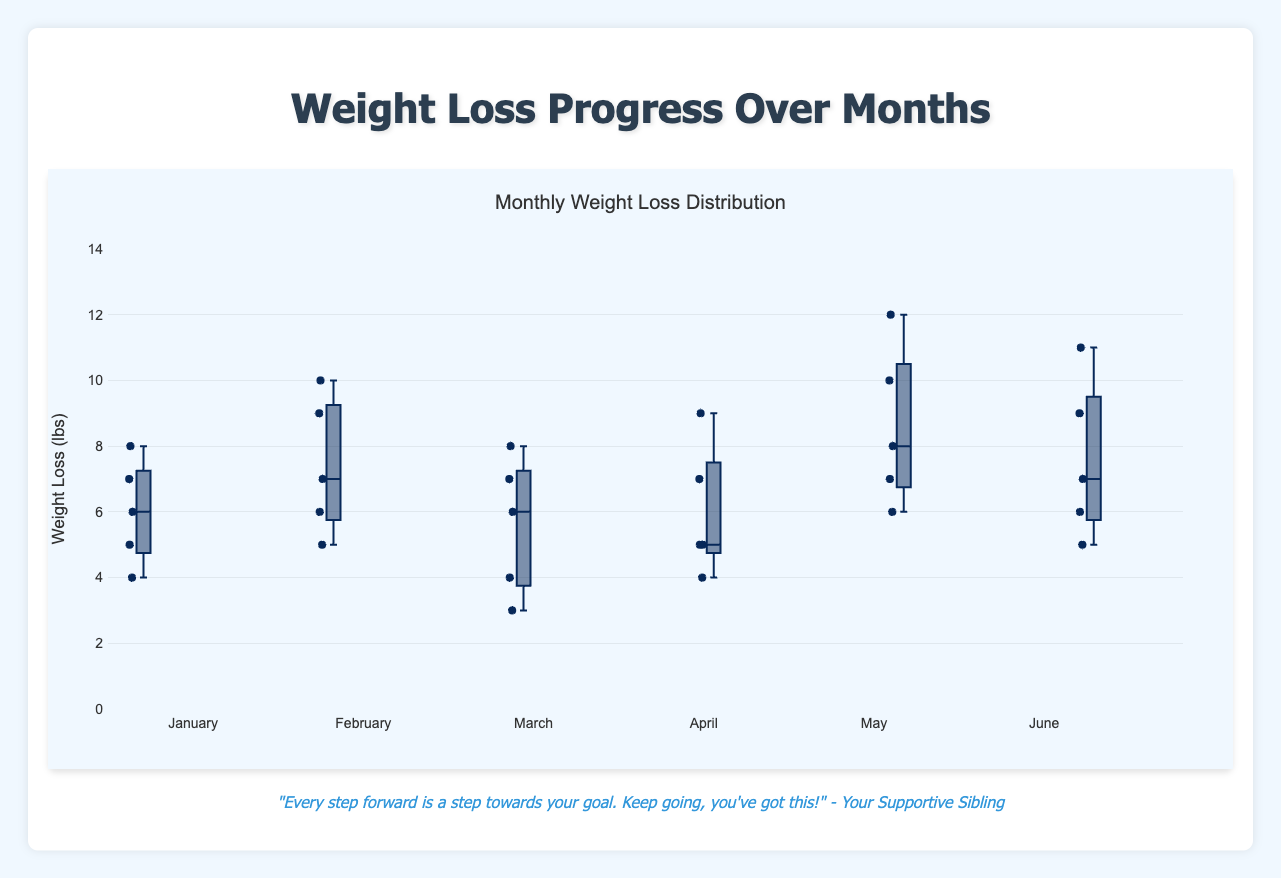What's the title of the plot? The title of the plot is located at the top of the chart and clearly indicates the content of the figure.
Answer: Monthly Weight Loss Distribution What does the y-axis represent? The label on the y-axis indicates the type of measurement used, which corresponds to the data points on the chart.
Answer: Weight Loss (lbs) Which month has the highest maximum weight loss? By examining the highest points of each box plot, you can determine which month has the highest maximum value. Look for the box with the longest whisker reaching upwards.
Answer: May What is the median weight loss for April? The median is represented by the line inside each box. Locate the median line within the box for April and read its value on the y-axis.
Answer: 5 lbs Whose weight loss is represented in June? For each month, individual data points are plotted within the box plot. Identifying the number of points can help in understanding who the participants are.
Answer: Alice, Bob, Charlie, David, Eve Compare the range of weight loss between January and February. Which month has a larger range? The range is the difference between the maximum and minimum values in each box plot. Identify the highest and lowest points (whiskers) of the boxes for both January and February and compare their ranges.
Answer: February What's the interquartile range (IQR) for March? The IQR is the difference between the third quartile (Q3) and the first quartile (Q1) in a box plot. Locate the top and bottom lines of the box for March and subtract the value of Q1 from Q3.
Answer: 2 lbs (between 3rd and 1st quartile values of 6 and 4 respectively) In which month did Alice experience the greatest weight loss? Locate Alice's weight loss values within the data provided and identify which value is the highest across all the months.
Answer: May Which month shows the smallest spread in weight loss? The spread is indicated by the length of the boxes and whiskers. Find the month where the box plot has the shortest length from top to bottom.
Answer: April Between January and June, in which month does Bob achieve his highest weight loss? Track Bob’s progress by comparing only his data points across all months and finding the highest value.
Answer: May 